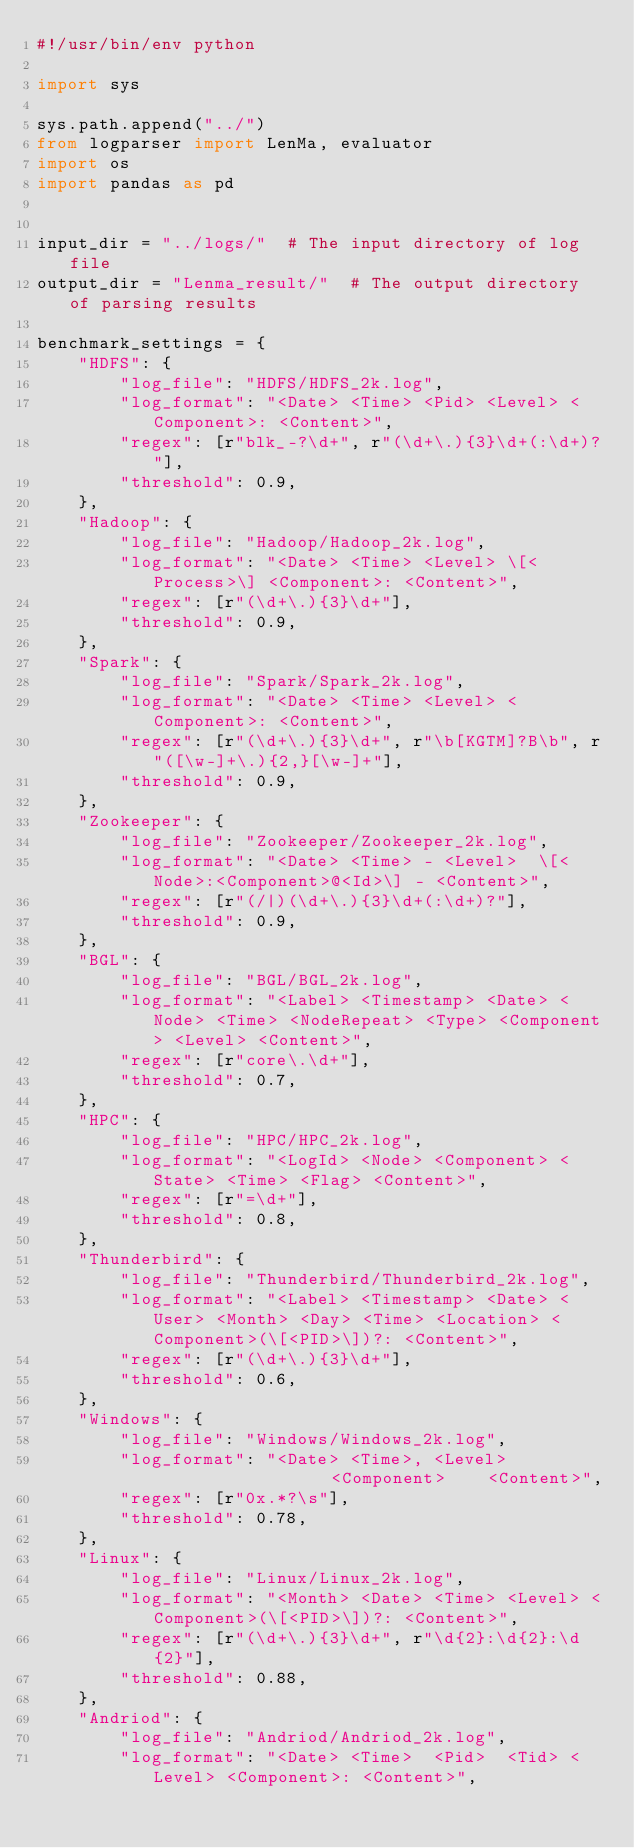Convert code to text. <code><loc_0><loc_0><loc_500><loc_500><_Python_>#!/usr/bin/env python

import sys

sys.path.append("../")
from logparser import LenMa, evaluator
import os
import pandas as pd


input_dir = "../logs/"  # The input directory of log file
output_dir = "Lenma_result/"  # The output directory of parsing results

benchmark_settings = {
    "HDFS": {
        "log_file": "HDFS/HDFS_2k.log",
        "log_format": "<Date> <Time> <Pid> <Level> <Component>: <Content>",
        "regex": [r"blk_-?\d+", r"(\d+\.){3}\d+(:\d+)?"],
        "threshold": 0.9,
    },
    "Hadoop": {
        "log_file": "Hadoop/Hadoop_2k.log",
        "log_format": "<Date> <Time> <Level> \[<Process>\] <Component>: <Content>",
        "regex": [r"(\d+\.){3}\d+"],
        "threshold": 0.9,
    },
    "Spark": {
        "log_file": "Spark/Spark_2k.log",
        "log_format": "<Date> <Time> <Level> <Component>: <Content>",
        "regex": [r"(\d+\.){3}\d+", r"\b[KGTM]?B\b", r"([\w-]+\.){2,}[\w-]+"],
        "threshold": 0.9,
    },
    "Zookeeper": {
        "log_file": "Zookeeper/Zookeeper_2k.log",
        "log_format": "<Date> <Time> - <Level>  \[<Node>:<Component>@<Id>\] - <Content>",
        "regex": [r"(/|)(\d+\.){3}\d+(:\d+)?"],
        "threshold": 0.9,
    },
    "BGL": {
        "log_file": "BGL/BGL_2k.log",
        "log_format": "<Label> <Timestamp> <Date> <Node> <Time> <NodeRepeat> <Type> <Component> <Level> <Content>",
        "regex": [r"core\.\d+"],
        "threshold": 0.7,
    },
    "HPC": {
        "log_file": "HPC/HPC_2k.log",
        "log_format": "<LogId> <Node> <Component> <State> <Time> <Flag> <Content>",
        "regex": [r"=\d+"],
        "threshold": 0.8,
    },
    "Thunderbird": {
        "log_file": "Thunderbird/Thunderbird_2k.log",
        "log_format": "<Label> <Timestamp> <Date> <User> <Month> <Day> <Time> <Location> <Component>(\[<PID>\])?: <Content>",
        "regex": [r"(\d+\.){3}\d+"],
        "threshold": 0.6,
    },
    "Windows": {
        "log_file": "Windows/Windows_2k.log",
        "log_format": "<Date> <Time>, <Level>                  <Component>    <Content>",
        "regex": [r"0x.*?\s"],
        "threshold": 0.78,
    },
    "Linux": {
        "log_file": "Linux/Linux_2k.log",
        "log_format": "<Month> <Date> <Time> <Level> <Component>(\[<PID>\])?: <Content>",
        "regex": [r"(\d+\.){3}\d+", r"\d{2}:\d{2}:\d{2}"],
        "threshold": 0.88,
    },
    "Andriod": {
        "log_file": "Andriod/Andriod_2k.log",
        "log_format": "<Date> <Time>  <Pid>  <Tid> <Level> <Component>: <Content>",</code> 